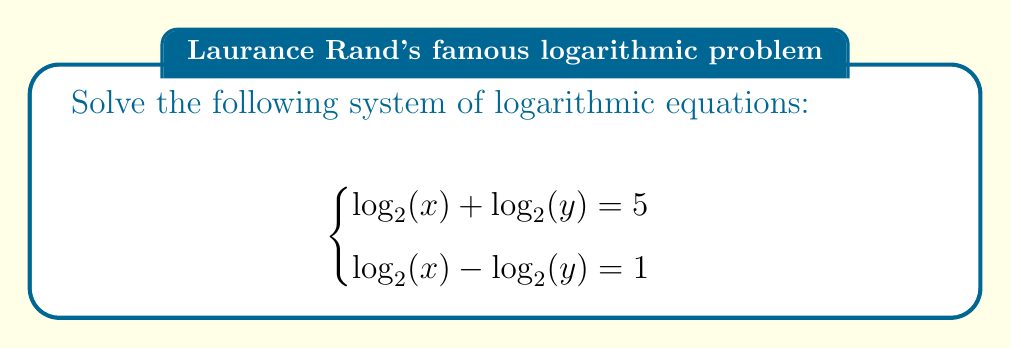Can you answer this question? Let's solve this step-by-step using substitution:

1) First, let's assign variables to each logarithmic expression:
   Let $a = \log_2(x)$ and $b = \log_2(y)$

2) Now our system becomes:
   $$\begin{cases}
   a + b = 5 \\
   a - b = 1
   \end{cases}$$

3) We can solve this system by adding the equations:
   $(a + b) + (a - b) = 5 + 1$
   $2a = 6$
   $a = 3$

4) Since $a = \log_2(x)$, we can find $x$:
   $\log_2(x) = 3$
   $x = 2^3 = 8$

5) Now we can substitute $a = 3$ into either of the original equations. Let's use $a + b = 5$:
   $3 + b = 5$
   $b = 2$

6) Since $b = \log_2(y)$, we can find $y$:
   $\log_2(y) = 2$
   $y = 2^2 = 4$

7) Let's verify our solution in both original equations:
   $\log_2(8) + \log_2(4) = 3 + 2 = 5$ (checks out)
   $\log_2(8) - \log_2(4) = 3 - 2 = 1$ (checks out)

Therefore, our solution is correct.
Answer: $x = 8, y = 4$ 